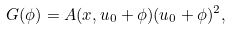Convert formula to latex. <formula><loc_0><loc_0><loc_500><loc_500>G ( \phi ) = A ( x , u _ { 0 } + \phi ) ( u _ { 0 } + \phi ) ^ { 2 } ,</formula> 